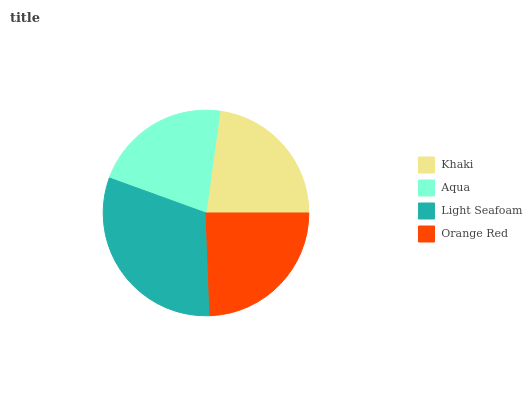Is Aqua the minimum?
Answer yes or no. Yes. Is Light Seafoam the maximum?
Answer yes or no. Yes. Is Light Seafoam the minimum?
Answer yes or no. No. Is Aqua the maximum?
Answer yes or no. No. Is Light Seafoam greater than Aqua?
Answer yes or no. Yes. Is Aqua less than Light Seafoam?
Answer yes or no. Yes. Is Aqua greater than Light Seafoam?
Answer yes or no. No. Is Light Seafoam less than Aqua?
Answer yes or no. No. Is Orange Red the high median?
Answer yes or no. Yes. Is Khaki the low median?
Answer yes or no. Yes. Is Aqua the high median?
Answer yes or no. No. Is Aqua the low median?
Answer yes or no. No. 